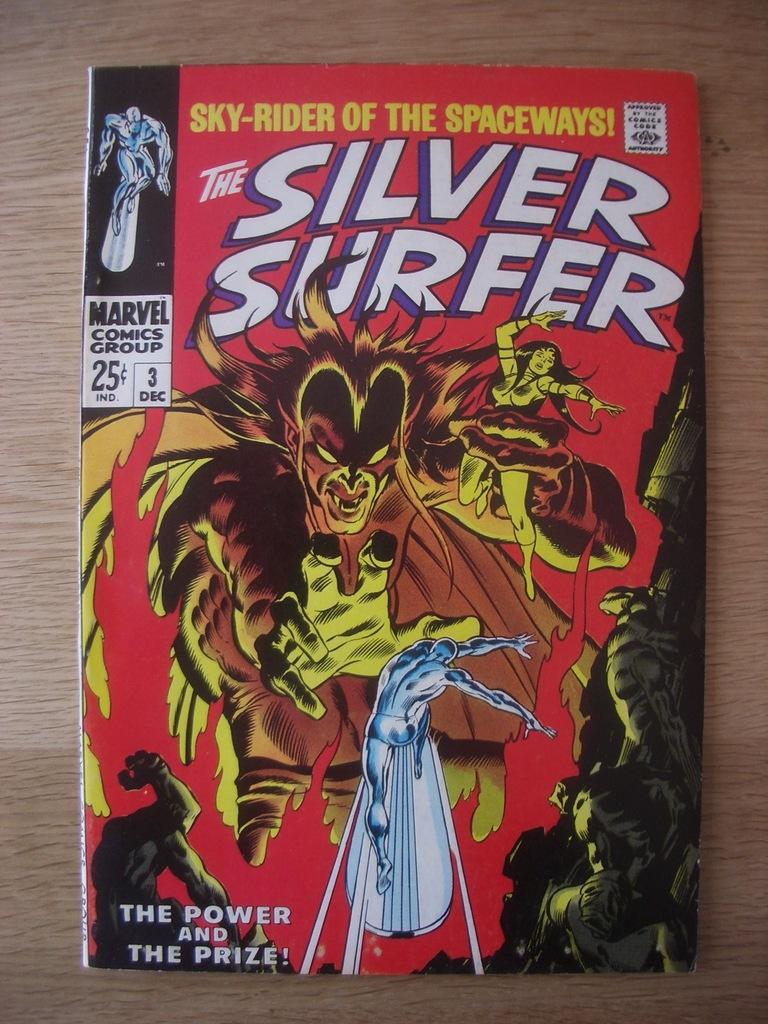<image>
Create a compact narrative representing the image presented. An issue of The Silver Surfer came out on the third of December. 